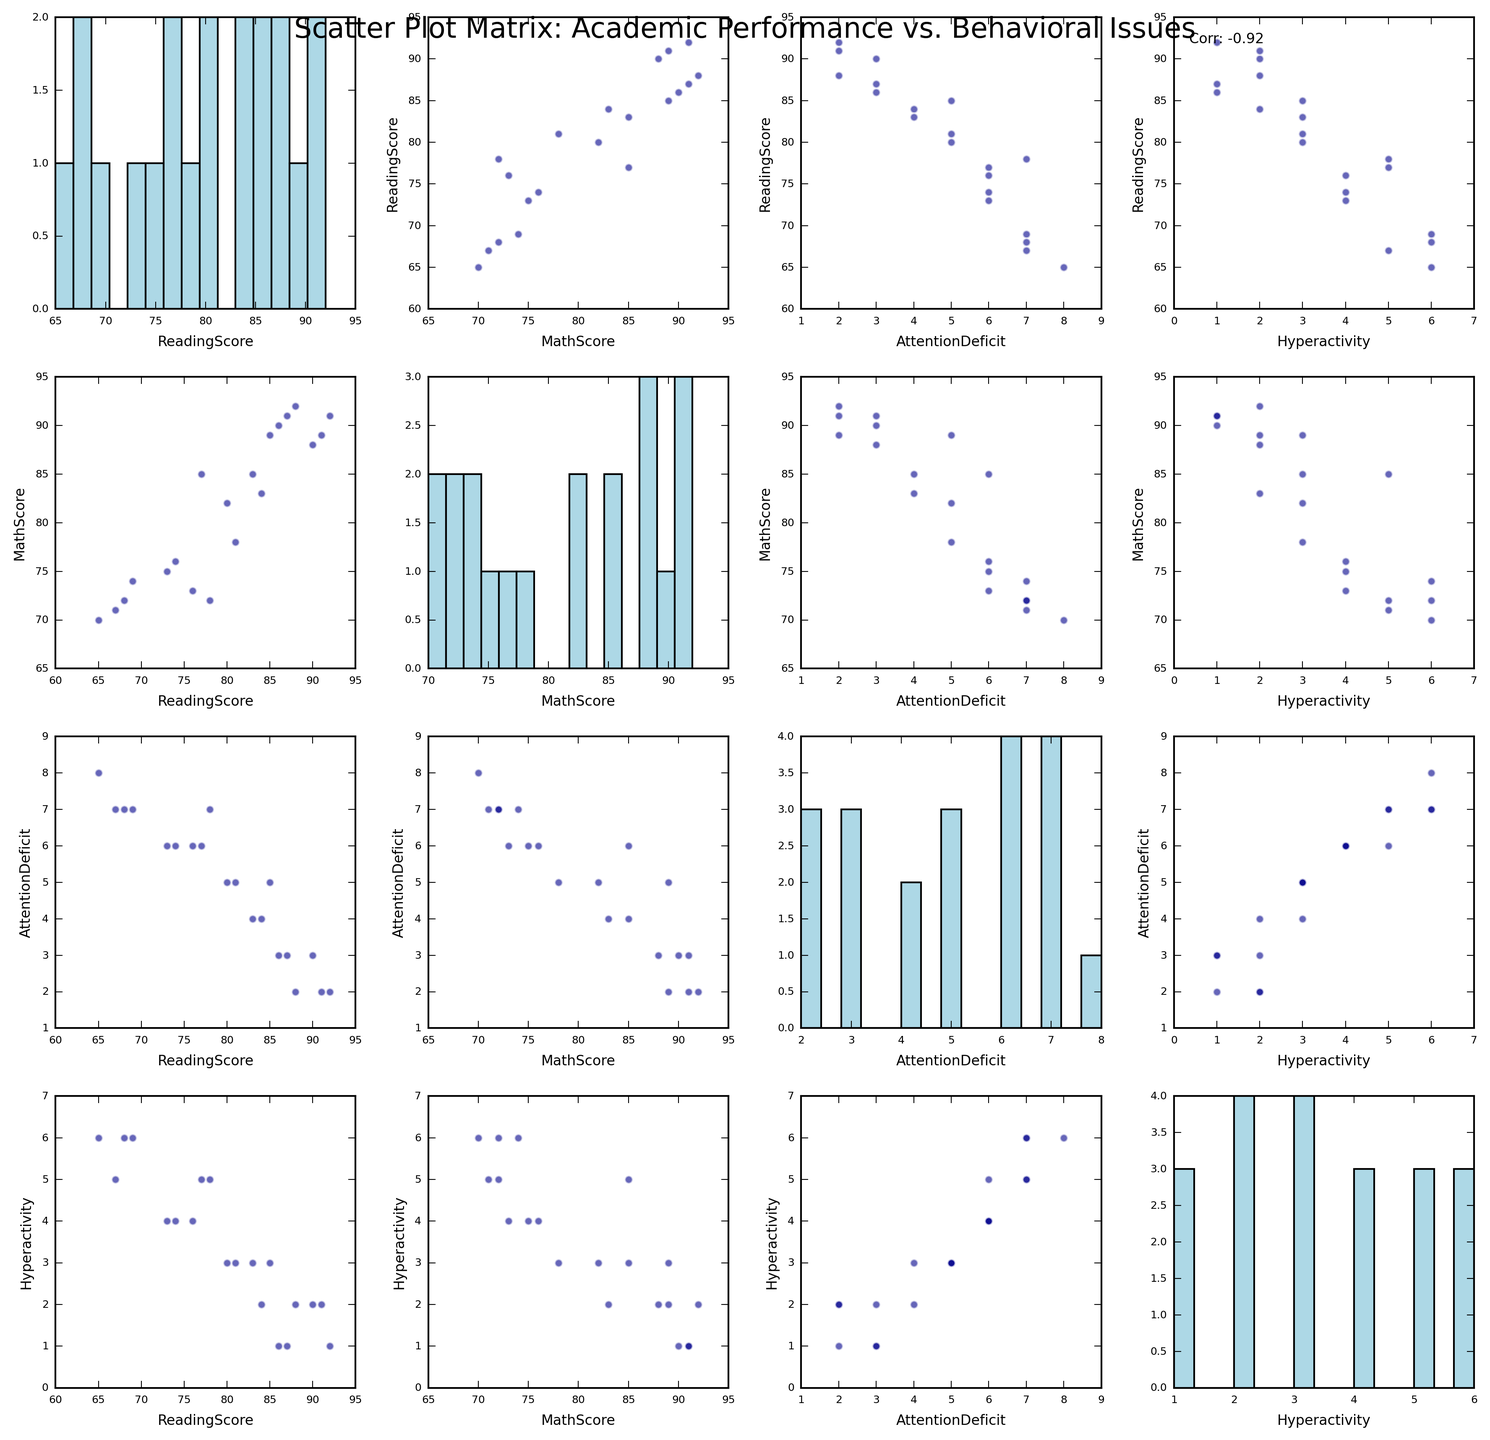What is the title of the scatter plot matrix? The title of a figure is typically displayed at the top and provides an overview of what the figure is about. According to the given information, the title should be "Scatter Plot Matrix: Academic Performance vs. Behavioral Issues".
Answer: Scatter Plot Matrix: Academic Performance vs. Behavioral Issues How many variables are analyzed in this scatter plot matrix? A scatter plot matrix shows multiple pairwise scatter plots for a set of variables. According to the given data, the variables are 'ReadingScore', 'MathScore', 'AttentionDeficit', and 'Hyperactivity', which means four variables are analyzed.
Answer: 4 What colors are used to represent individual data points in the scatter plots? The scatter plots use dots to represent data points. According to the given code, the color of these dots is specified as 'darkblue'.
Answer: Dark blue How many bins are used in the histograms on the diagonal? The histograms on the diagonal show the distribution of each variable. According to the provided code, each histogram uses 15 bins.
Answer: 15 Which pair of variables has their correlation coefficient annotated on the scatter plot matrix? In a Scatter Plot Matrix, the correlation coefficient is sometimes annotated for specific pairs of variables to highlight their relationship. According to the given code, the correlation coefficient is annotated between the first and last variables ('ReadingScore' and 'Hyperactivity').
Answer: ReadingScore and Hyperactivity Are there more students with high attention deficit scores or high reading scores? High scores are those that are closer to the upper end of the scale. By looking at the histograms on the diagonal, one can compare the spread and height of bars for 'AttentionDeficit' and 'ReadingScore'. The 'ReadingScore' histogram generally shows higher values concentrated towards the upper end compared to 'AttentionDeficit'.
Answer: High reading scores Which pair of variables shows the most scattered data points in their scatter plot? A more scattered plot suggests a weaker correlation. By examining the scatter plots, the 'AttentionDeficit' vs 'MathScore' pair appears very scattered, indicating a lower correlation.
Answer: AttentionDeficit vs. MathScore Is there a noticeable trend between Reading Scores and Hyperactivity? By examining the scatter plot between 'ReadingScore' and 'Hyperactivity', we can see if there is a trend. The plot shows a downward spread, indicating that higher reading scores might be associated with lower hyperactivity.
Answer: Inverse trend What is the visible relationship between Math Scores and Attention Deficit? To determine the relationship, check the scatter plot between 'MathScore' and 'AttentionDeficit'. According to the visual information, higher attention deficit scores seem to be associated with lower math scores.
Answer: Negative relationship How do hyperactivity scores correlate with attention deficit scores based on the scatter plot? We look at the scatter plot between 'Hyperactivity' and 'AttentionDeficit'. The clustering of data points along a trendline helps to determine the relationship. From the visual inspection, there appears to be a positive correlation.
Answer: Positive correlation 